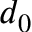<formula> <loc_0><loc_0><loc_500><loc_500>d _ { 0 }</formula> 